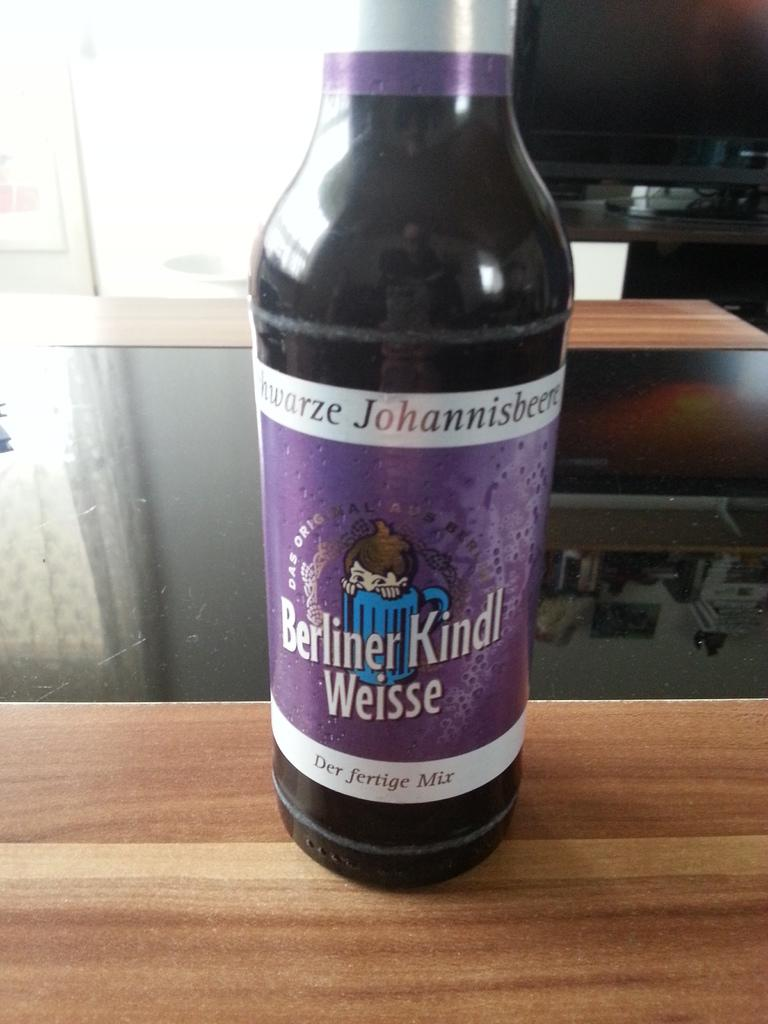<image>
Give a short and clear explanation of the subsequent image. A bottle of Berliner Kindl Weisse sits on a table. 